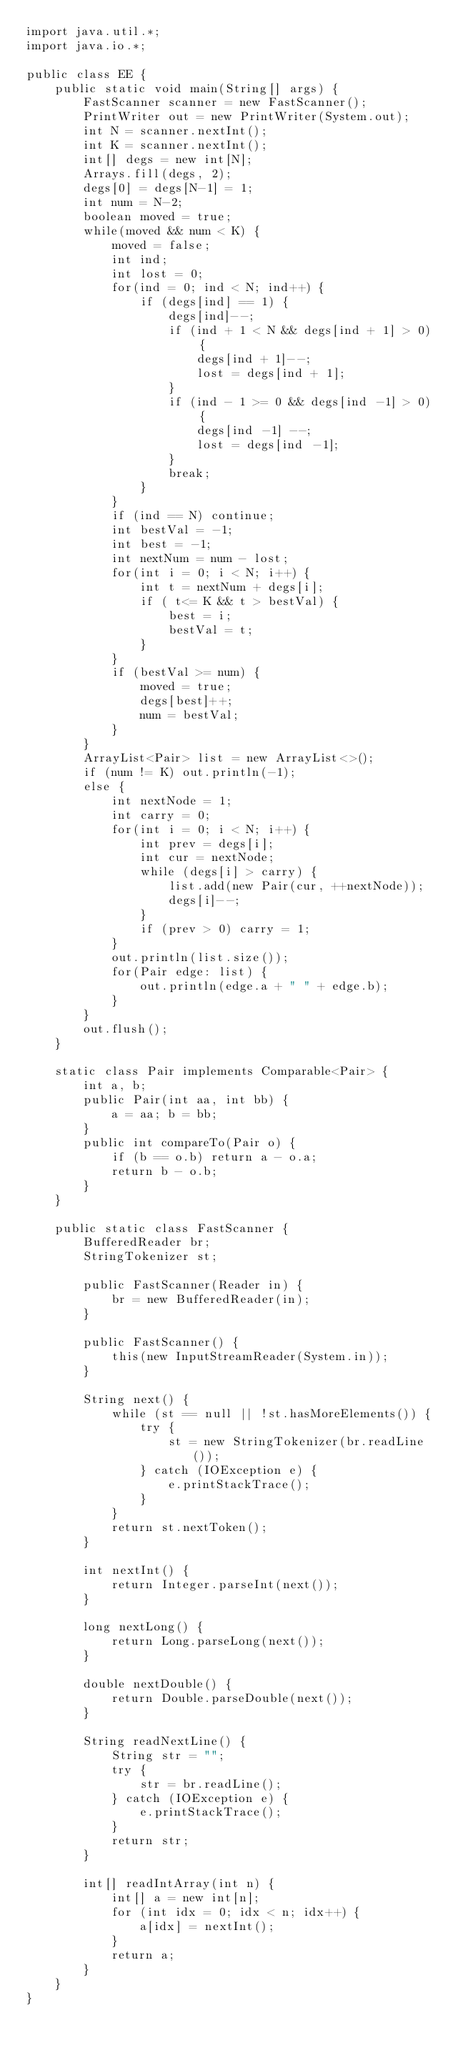Convert code to text. <code><loc_0><loc_0><loc_500><loc_500><_Java_>import java.util.*;
import java.io.*;

public class EE {
    public static void main(String[] args) {
        FastScanner scanner = new FastScanner();
        PrintWriter out = new PrintWriter(System.out);
        int N = scanner.nextInt();
        int K = scanner.nextInt();
        int[] degs = new int[N];
        Arrays.fill(degs, 2);
        degs[0] = degs[N-1] = 1;
        int num = N-2;
        boolean moved = true;
        while(moved && num < K) {
            moved = false;
            int ind;
            int lost = 0;
            for(ind = 0; ind < N; ind++) {
                if (degs[ind] == 1) {
                    degs[ind]--;
                    if (ind + 1 < N && degs[ind + 1] > 0) {
                        degs[ind + 1]--;
                        lost = degs[ind + 1];
                    }
                    if (ind - 1 >= 0 && degs[ind -1] > 0) {
                        degs[ind -1] --;
                        lost = degs[ind -1];
                    }
                    break;
                }
            }
            if (ind == N) continue;
            int bestVal = -1;
            int best = -1;
            int nextNum = num - lost;
            for(int i = 0; i < N; i++) {
                int t = nextNum + degs[i];
                if ( t<= K && t > bestVal) {
                    best = i;
                    bestVal = t;
                }
            }
            if (bestVal >= num) {
                moved = true;
                degs[best]++;
                num = bestVal;
            }
        }
        ArrayList<Pair> list = new ArrayList<>();
        if (num != K) out.println(-1);
        else {
            int nextNode = 1;
            int carry = 0;
            for(int i = 0; i < N; i++) {
                int prev = degs[i];
                int cur = nextNode;
                while (degs[i] > carry) {
                    list.add(new Pair(cur, ++nextNode));
                    degs[i]--;
                }
                if (prev > 0) carry = 1;
            }
            out.println(list.size());
            for(Pair edge: list) {
                out.println(edge.a + " " + edge.b);
            }
        }
        out.flush();
    }
    
    static class Pair implements Comparable<Pair> {
        int a, b;
        public Pair(int aa, int bb) {
            a = aa; b = bb;
        }
        public int compareTo(Pair o) {
            if (b == o.b) return a - o.a;
            return b - o.b;
        }
    }
    
    public static class FastScanner {
        BufferedReader br;
        StringTokenizer st;
        
        public FastScanner(Reader in) {
            br = new BufferedReader(in);
        }
        
        public FastScanner() {
            this(new InputStreamReader(System.in));
        }
        
        String next() {
            while (st == null || !st.hasMoreElements()) {
                try {
                    st = new StringTokenizer(br.readLine());
                } catch (IOException e) {
                    e.printStackTrace();
                }
            }
            return st.nextToken();
        }
        
        int nextInt() {
            return Integer.parseInt(next());
        }
        
        long nextLong() {
            return Long.parseLong(next());
        }
        
        double nextDouble() {
            return Double.parseDouble(next());
        }
        
        String readNextLine() {
            String str = "";
            try {
                str = br.readLine();
            } catch (IOException e) {
                e.printStackTrace();
            }
            return str;
        }
        
        int[] readIntArray(int n) {
            int[] a = new int[n];
            for (int idx = 0; idx < n; idx++) {
                a[idx] = nextInt();
            }
            return a;
        }
    }
}
</code> 